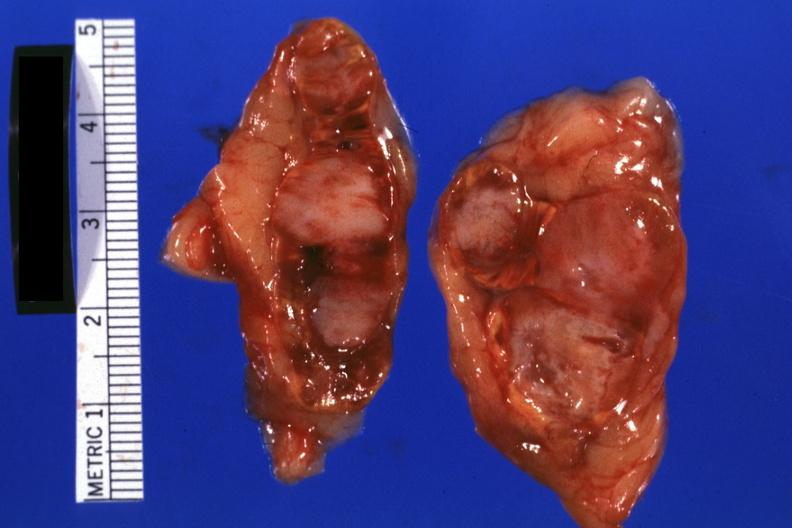does this image show excellent example lul scar adenocarcinoma?
Answer the question using a single word or phrase. Yes 